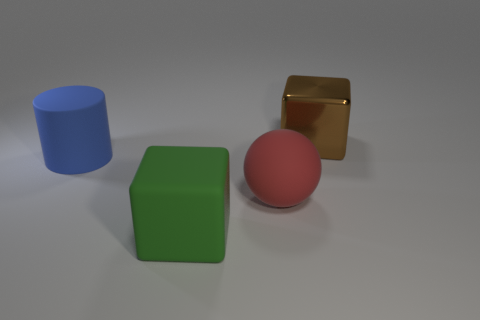Are there any green rubber objects that have the same shape as the big metallic thing?
Your answer should be very brief. Yes. The big red thing is what shape?
Make the answer very short. Sphere. What number of things are either tiny cyan things or large rubber objects?
Make the answer very short. 3. How many other things are there of the same material as the brown thing?
Make the answer very short. 0. Is the number of large objects that are left of the large brown metal cube greater than the number of red balls that are behind the large blue rubber cylinder?
Provide a succinct answer. Yes. What is the material of the big cube right of the large green rubber thing?
Your answer should be very brief. Metal. Is the shape of the red thing the same as the big brown metallic object?
Provide a succinct answer. No. The large rubber thing that is the same shape as the brown shiny thing is what color?
Offer a terse response. Green. Is the number of blocks on the left side of the brown metallic thing greater than the number of small red shiny balls?
Your answer should be compact. Yes. There is a rubber thing behind the big red object; what is its color?
Your answer should be very brief. Blue. 